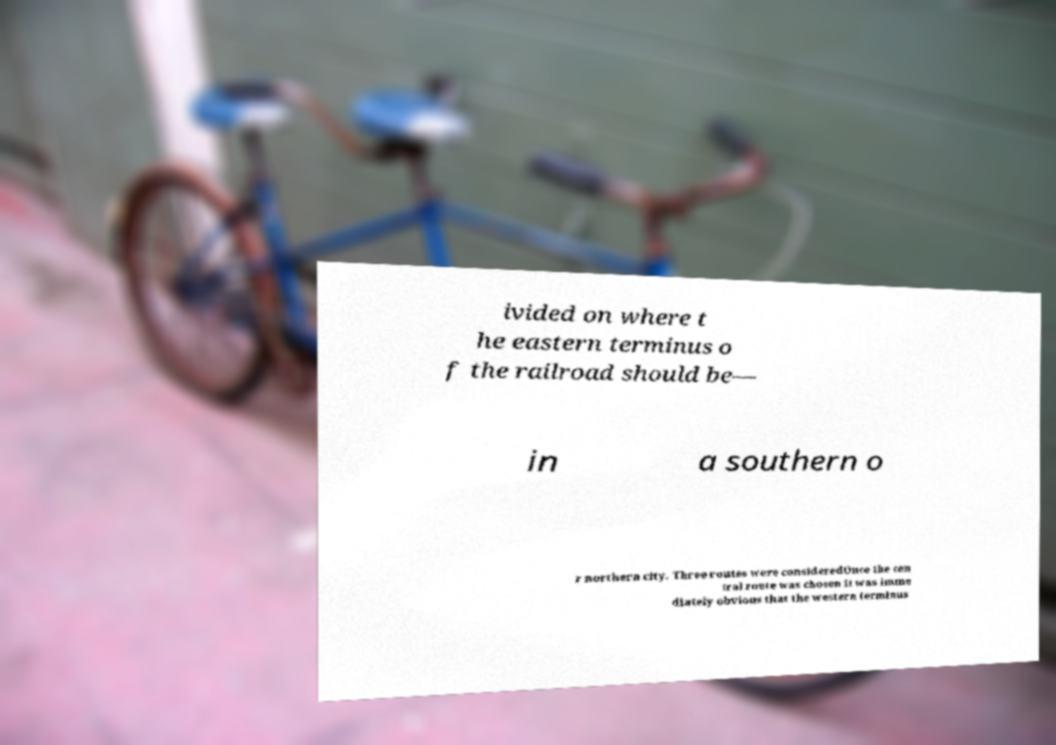Can you read and provide the text displayed in the image?This photo seems to have some interesting text. Can you extract and type it out for me? ivided on where t he eastern terminus o f the railroad should be— in a southern o r northern city. Three routes were consideredOnce the cen tral route was chosen it was imme diately obvious that the western terminus 